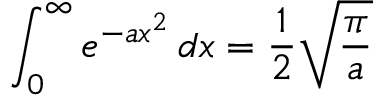Convert formula to latex. <formula><loc_0><loc_0><loc_500><loc_500>\int _ { 0 } ^ { \infty } e ^ { - a x ^ { 2 } } \, d x = { \frac { 1 } { 2 } } { \sqrt { \frac { \pi } { a } } }</formula> 